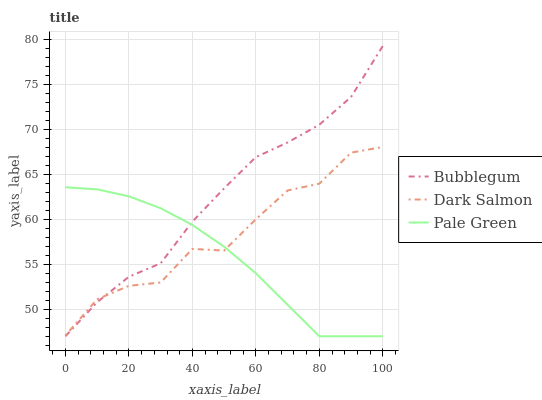Does Pale Green have the minimum area under the curve?
Answer yes or no. Yes. Does Bubblegum have the maximum area under the curve?
Answer yes or no. Yes. Does Dark Salmon have the minimum area under the curve?
Answer yes or no. No. Does Dark Salmon have the maximum area under the curve?
Answer yes or no. No. Is Pale Green the smoothest?
Answer yes or no. Yes. Is Dark Salmon the roughest?
Answer yes or no. Yes. Is Bubblegum the smoothest?
Answer yes or no. No. Is Bubblegum the roughest?
Answer yes or no. No. Does Dark Salmon have the lowest value?
Answer yes or no. No. Does Bubblegum have the highest value?
Answer yes or no. Yes. Does Dark Salmon have the highest value?
Answer yes or no. No. Does Dark Salmon intersect Pale Green?
Answer yes or no. Yes. Is Dark Salmon less than Pale Green?
Answer yes or no. No. Is Dark Salmon greater than Pale Green?
Answer yes or no. No. 